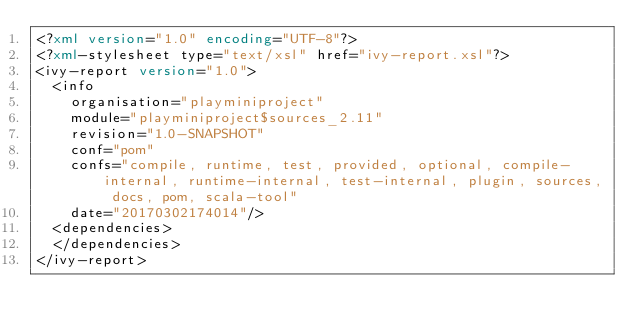<code> <loc_0><loc_0><loc_500><loc_500><_XML_><?xml version="1.0" encoding="UTF-8"?>
<?xml-stylesheet type="text/xsl" href="ivy-report.xsl"?>
<ivy-report version="1.0">
	<info
		organisation="playminiproject"
		module="playminiproject$sources_2.11"
		revision="1.0-SNAPSHOT"
		conf="pom"
		confs="compile, runtime, test, provided, optional, compile-internal, runtime-internal, test-internal, plugin, sources, docs, pom, scala-tool"
		date="20170302174014"/>
	<dependencies>
	</dependencies>
</ivy-report>
</code> 